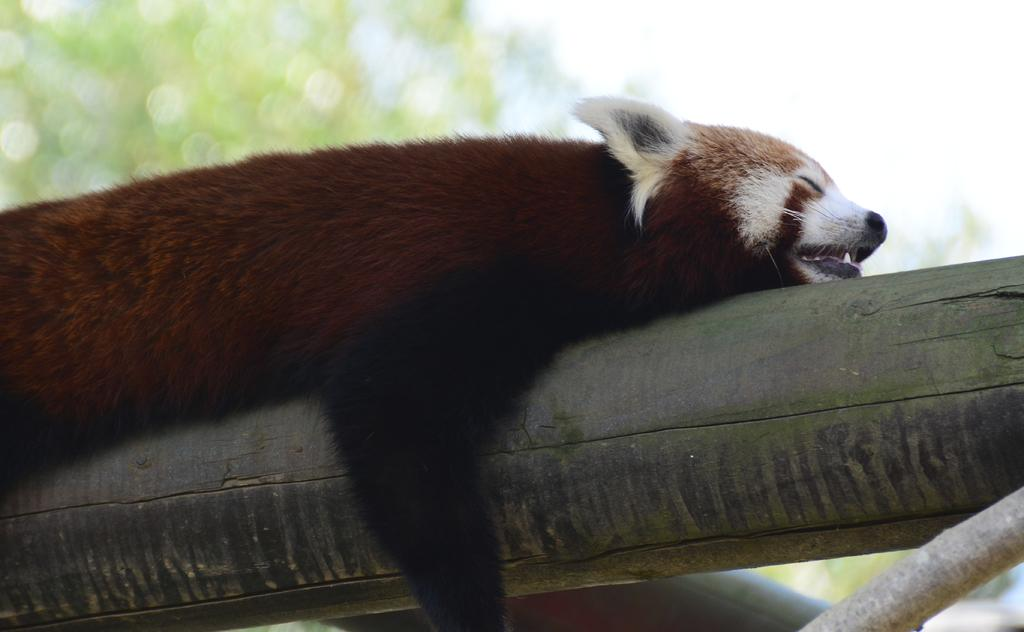What type of animal is in the image? There is a red panda in the image. What is the red panda lying on? The red panda is lying on a wooden log. What else can be seen in the image besides the red panda? There is a branch of a tree in the image. What is visible in the background of the image? There is a tree and the sky visible in the background of the image. What is the red panda arguing about with the car in the image? There is no car present in the image, and therefore no argument can be observed. 